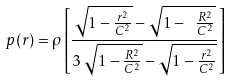<formula> <loc_0><loc_0><loc_500><loc_500>p ( r ) = \rho \left [ \frac { { \sqrt { 1 - \frac { r ^ { 2 } } { C ^ { 2 } } } } - { \sqrt { 1 - \ \frac { R ^ { 2 } } { C ^ { 2 } } } } } { 3 \, { \sqrt { 1 - \frac { R ^ { 2 } } { C ^ { 2 } } } } - { \sqrt { 1 - \frac { r ^ { 2 } } { C ^ { 2 } } } } } \right ]</formula> 